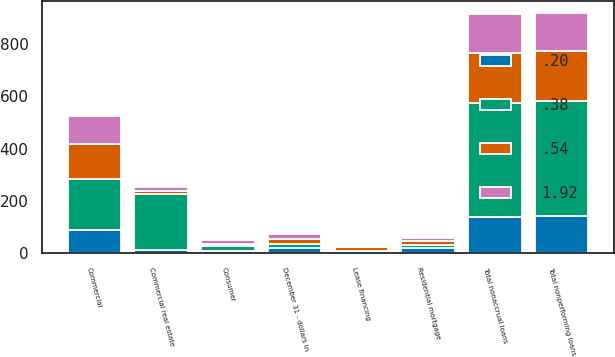Convert chart to OTSL. <chart><loc_0><loc_0><loc_500><loc_500><stacked_bar_chart><ecel><fcel>December 31 - dollars in<fcel>Commercial<fcel>Lease financing<fcel>Commercial real estate<fcel>Consumer<fcel>Residential mortgage<fcel>Total nonaccrual loans<fcel>Total nonperforming loans<nl><fcel>0.38<fcel>19<fcel>193<fcel>3<fcel>212<fcel>17<fcel>10<fcel>435<fcel>437<nl><fcel>1.92<fcel>19<fcel>109<fcel>1<fcel>12<fcel>13<fcel>12<fcel>147<fcel>147<nl><fcel>0.54<fcel>19<fcel>134<fcel>17<fcel>14<fcel>10<fcel>15<fcel>190<fcel>190<nl><fcel>0.2<fcel>19<fcel>89<fcel>5<fcel>14<fcel>11<fcel>21<fcel>140<fcel>143<nl></chart> 